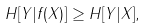<formula> <loc_0><loc_0><loc_500><loc_500>H [ Y | f ( X ) ] \geq H [ Y | X ] ,</formula> 